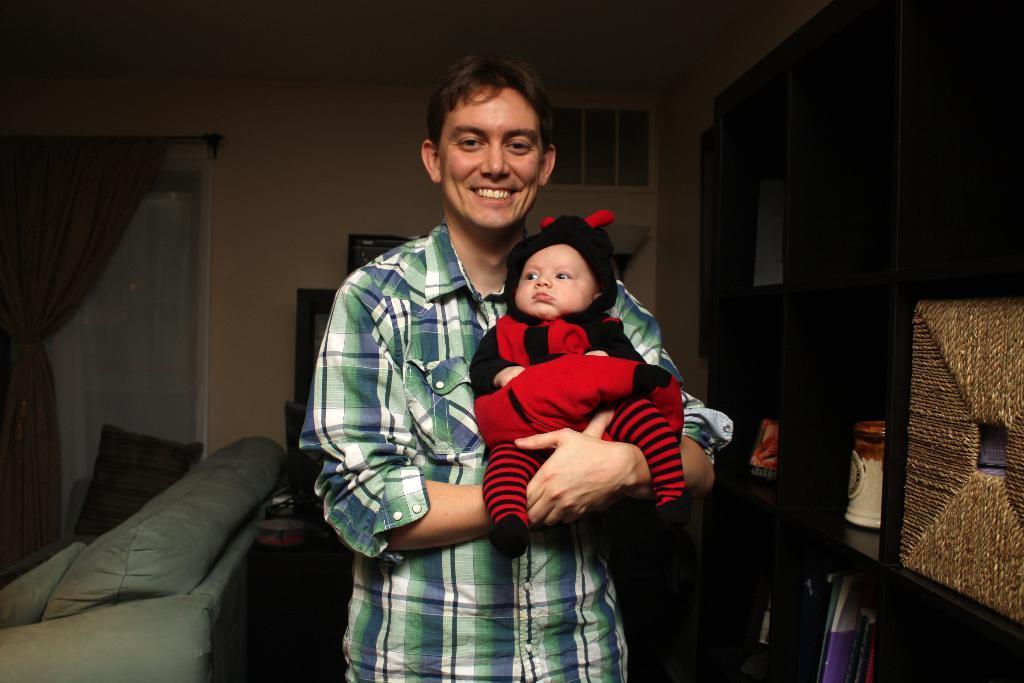Describe this image in one or two sentences. This is the man holding a baby and standing. He is smiling. This looks like a couch with the cushions on it. Here is a curtain hanging to the hanger. This looks like a door. I can see few objects placed in the wooden rack. In the background, that looks like an object. 